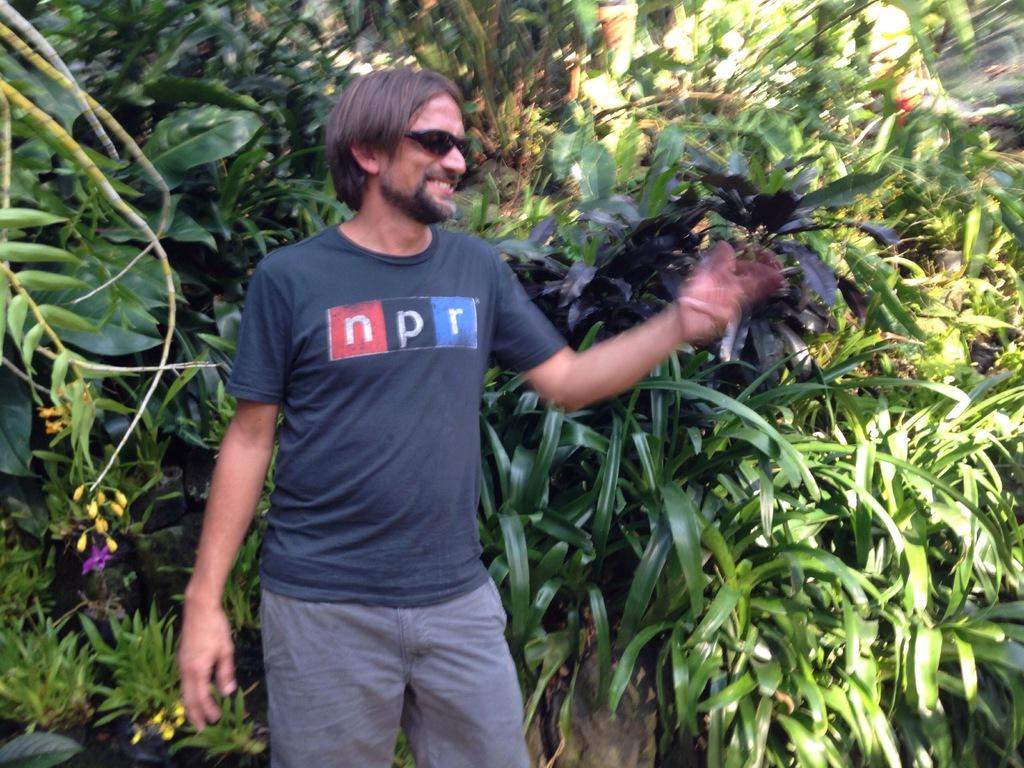What is the main subject of the image? There is a man standing in the image. What can be seen in the background of the image? There are trees visible behind the man in the image. Can you see a snail crawling on the man's shoulder in the image? No, there is no snail visible on the man's shoulder in the image. 